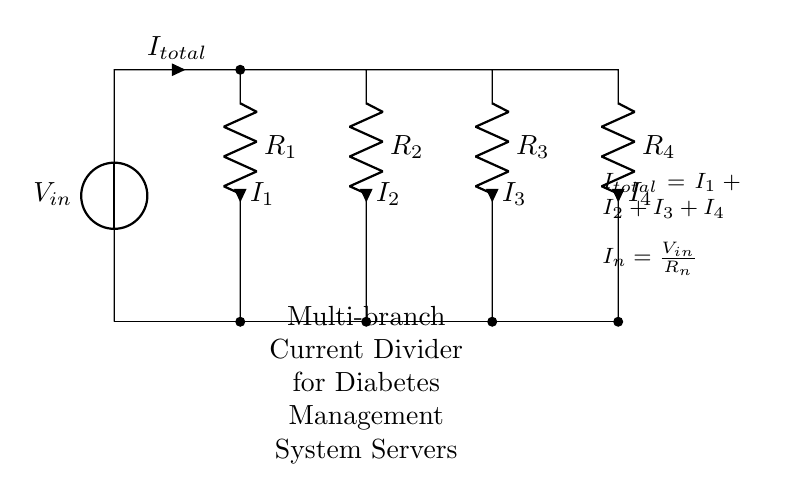What is the type of the main circuit configuration? The circuit is a current divider because it splits the total current into multiple branches, each with its own resistor. This is evident from the parallel connection of the resistors and the summation of the currents at the input.
Answer: Current divider What is the total current entering the circuit? The total current is represented by I total, which is the sum of the individual branch currents (I1, I2, I3, and I4). The circuit shows this with the notation I total = I1 + I2 + I3 + I4, indicating that these currents flow from the input source.
Answer: I total How many resistors are in the circuit? The diagram shows four resistors labeled R1, R2, R3, and R4, which are all connected in parallel to the input current source. This can be counted directly from the circuit diagram.
Answer: Four What is the relationship between the input voltage and branch currents? Each branch current I n is derived from the input voltage V in and its corresponding resistor R n, as shown by the formula I n = V in / R n indicated in the diagram. This explains how the voltage is distributed among the branches based on their resistance values.
Answer: I n = V in / R n If R1 is 10 ohms and Vin is 20V, what is I1? Applying the formula for the current in terms of resistance and voltage, I1 = Vin / R1 = 20V / 10 ohms. This calculation shows how the total current divider formula is directly applied to find the current through a specific resistor.
Answer: 2A Which resistor has the largest current? The resistor with the smallest value will have the largest current due to the nature of the current divider. While the specific values are not given here, generally, among R1, R2, R3, and R4, the smallest resistance value results in the highest current, as indicated by the relationship I n = V in / R n.
Answer: Depends on resistor values 